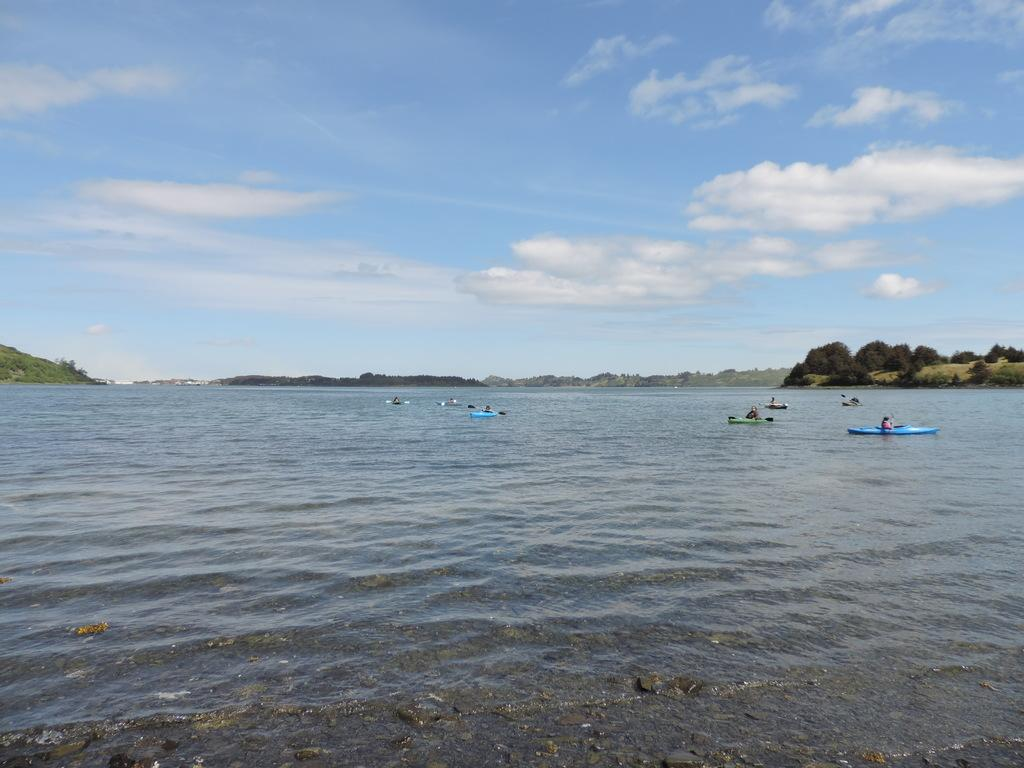What is the main feature of the image? The center of the image contains the sky. What can be seen in the sky? Clouds are visible in the sky. What type of natural environment is depicted in the image? Trees are present in the image, and there is water as well. What is floating on the water? Boats are visible in the water. Are there any other objects in the image besides the sky, clouds, trees, water, and boats? Yes, there are a few other objects in the image. What type of spoon is being used by the bear to teach the other animals in the image? There are no bears or teaching activities present in the image. 